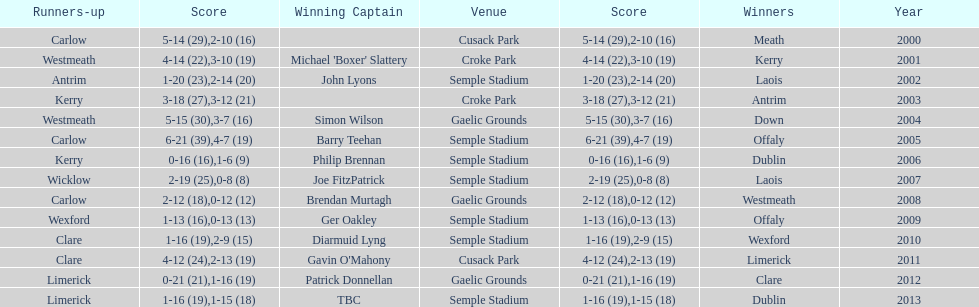Who was the winning captain the last time the competition was held at the gaelic grounds venue? Patrick Donnellan. 